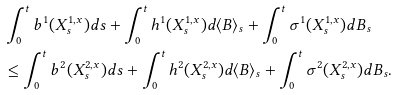Convert formula to latex. <formula><loc_0><loc_0><loc_500><loc_500>& \int ^ { t } _ { 0 } b ^ { 1 } ( X ^ { 1 , x } _ { s } ) d s + \int ^ { t } _ { 0 } h ^ { 1 } ( X ^ { 1 , x } _ { s } ) d \langle B \rangle _ { s } + \int ^ { t } _ { 0 } \sigma ^ { 1 } ( X ^ { 1 , x } _ { s } ) d B _ { s } \\ & \leq \int ^ { t } _ { 0 } b ^ { 2 } ( X ^ { 2 , x } _ { s } ) d s + \int ^ { t } _ { 0 } h ^ { 2 } ( X ^ { 2 , x } _ { s } ) d \langle B \rangle _ { s } + \int ^ { t } _ { 0 } \sigma ^ { 2 } ( X ^ { 2 , x } _ { s } ) d B _ { s } .</formula> 